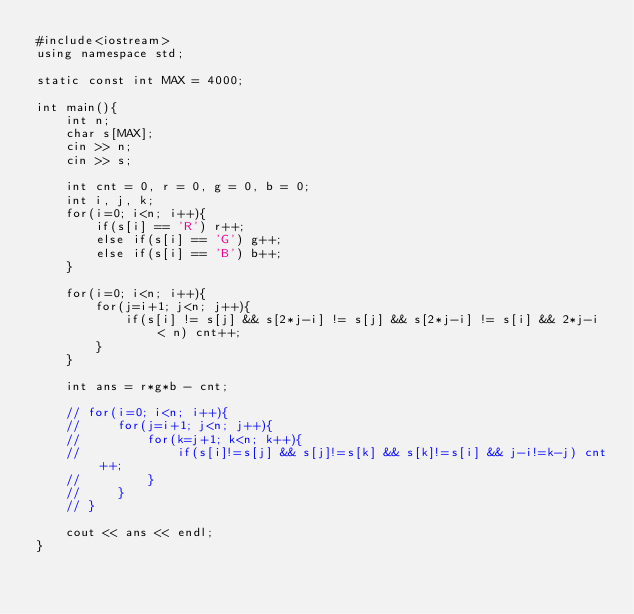Convert code to text. <code><loc_0><loc_0><loc_500><loc_500><_C_>#include<iostream>
using namespace std;

static const int MAX = 4000;

int main(){
    int n;
    char s[MAX];
    cin >> n;
    cin >> s;

    int cnt = 0, r = 0, g = 0, b = 0;
    int i, j, k;
    for(i=0; i<n; i++){
        if(s[i] == 'R') r++;
        else if(s[i] == 'G') g++;
        else if(s[i] == 'B') b++;
    }

    for(i=0; i<n; i++){
        for(j=i+1; j<n; j++){
            if(s[i] != s[j] && s[2*j-i] != s[j] && s[2*j-i] != s[i] && 2*j-i < n) cnt++;
        }
    }

    int ans = r*g*b - cnt;
    
    // for(i=0; i<n; i++){
    //     for(j=i+1; j<n; j++){
    //         for(k=j+1; k<n; k++){
    //             if(s[i]!=s[j] && s[j]!=s[k] && s[k]!=s[i] && j-i!=k-j) cnt++;
    //         }
    //     }
    // }

    cout << ans << endl;
}
</code> 